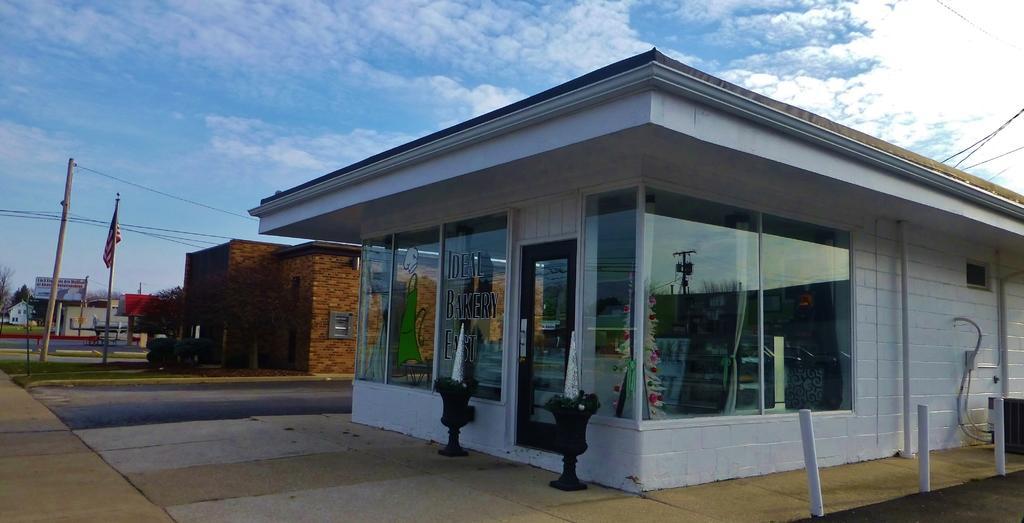Describe this image in one or two sentences. In this image, at the right side there is a white color shop, there are two black color objects on the ground, in the background there is a house and there is a pole, at the top there is a blue color sky and there are some white color clouds. 